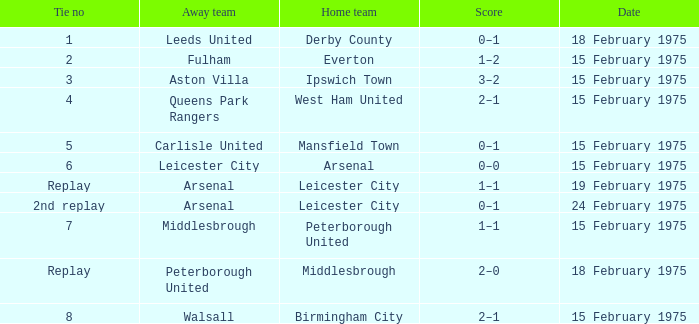When did the match occur with carlisle united as the visiting team? 15 February 1975. 